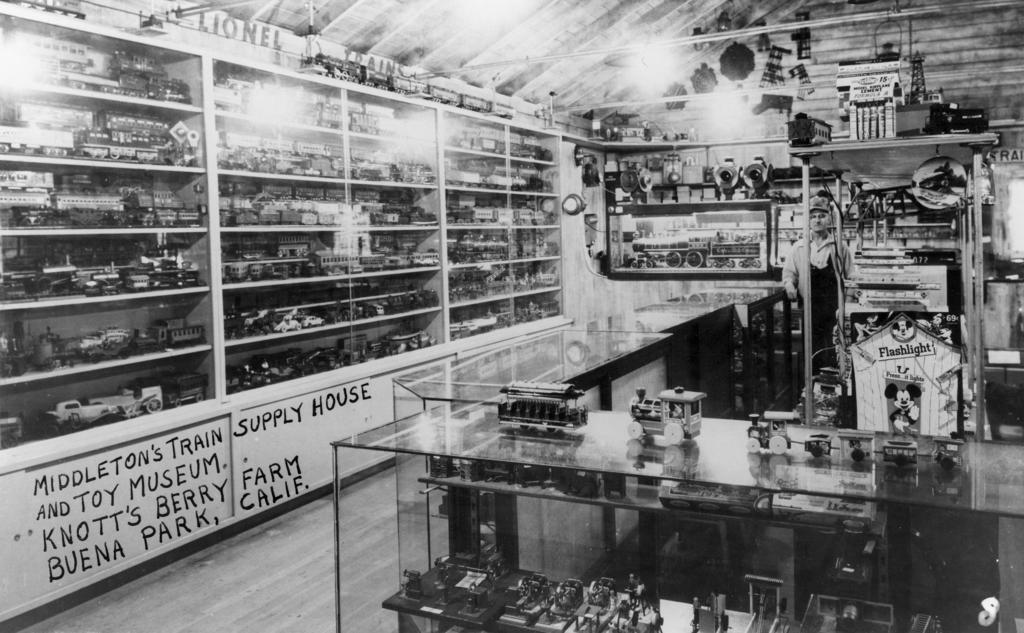What type of supply house is this?
Give a very brief answer. Train. Where is knott's berry farm located?
Offer a terse response. Buena park, california. 